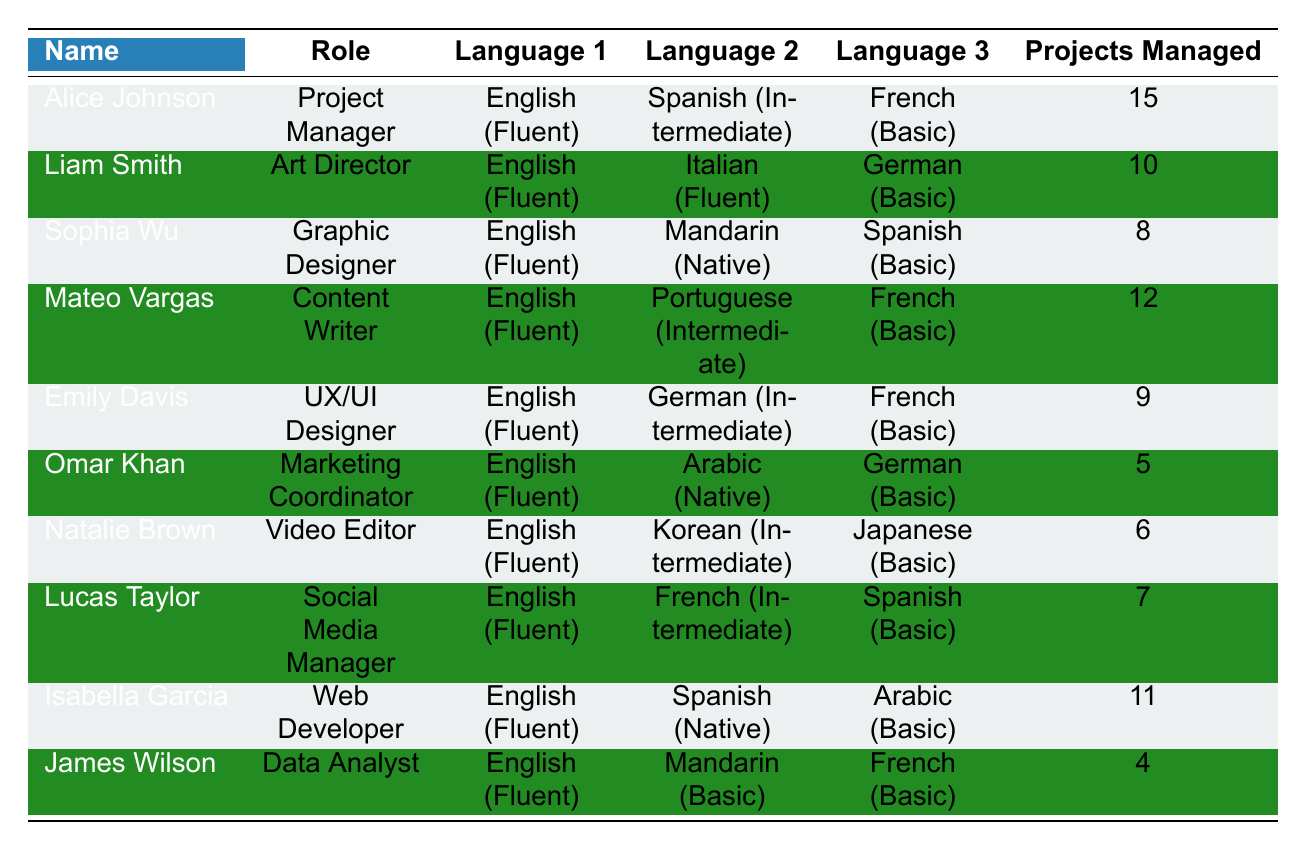What is the role of Sophia Wu? According to the table, Sophia Wu is listed as the Graphic Designer.
Answer: Graphic Designer How many projects did Alice Johnson manage? The table shows that Alice Johnson managed 15 projects.
Answer: 15 Which team member is fluent in Italian? Liam Smith is fluent in Italian as per the language proficiency listed in the table.
Answer: Liam Smith What is the average number of projects managed by the team? The total number of projects managed is 15 + 10 + 8 + 12 + 9 + 5 + 6 + 7 + 11 + 4 = 87. There are 10 team members, so the average is 87/10 = 8.7.
Answer: 8.7 Which languages does Mateo Vargas speak at an intermediate level? The table indicates that Mateo Vargas speaks Portuguese at an intermediate level.
Answer: Portuguese Is Emily Davis fluent in German? The table shows that Emily Davis is intermediate in German, not fluent.
Answer: No How many team members are fluent in Spanish? By examining the table, we see that Alice Johnson, Sophia Wu, Lucas Taylor, and Isabella Garcia are fluent in Spanish, making a total of 4 members.
Answer: 4 What is the total number of projects managed by members who are fluent in Arabic? Omar Khan and Isabella Garcia are fluent in Arabic. They managed 5 and 11 projects respectively, so the total is 5 + 11 = 16.
Answer: 16 Which team member managed the fewest projects, and how many did they manage? James Wilson is the one who managed the fewest projects with a total of 4 projects.
Answer: James Wilson, 4 If we consider only those who managed more than 10 projects, how many different languages are spoken fluently by those members? The team members managing more than 10 projects are Alice Johnson (Fluent in English, Spanish), Mateo Vargas (Fluent in English, Portuguese), and Isabella Garcia (Fluent in English, Spanish). Counting distinct fluent languages: English, Spanish, Portuguese. That makes 3 different languages.
Answer: 3 